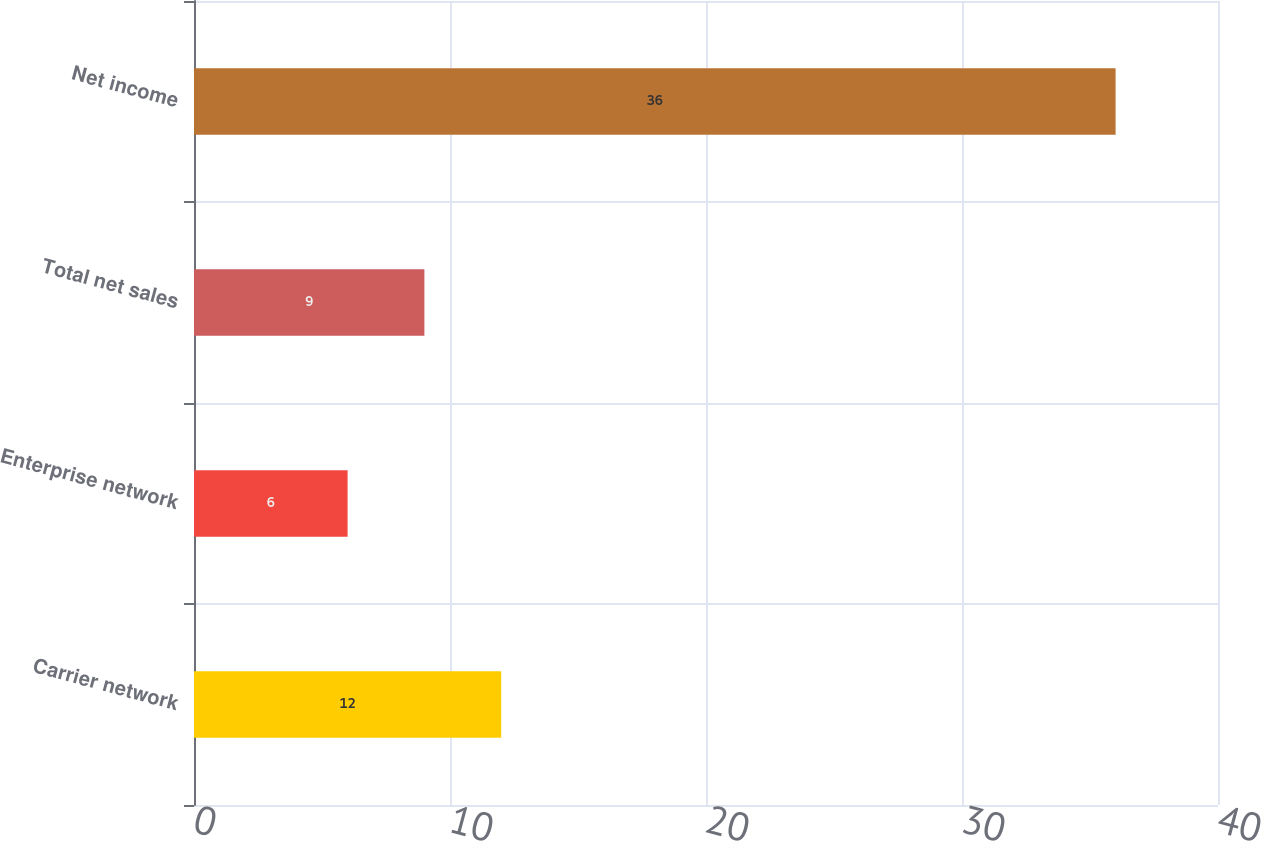Convert chart to OTSL. <chart><loc_0><loc_0><loc_500><loc_500><bar_chart><fcel>Carrier network<fcel>Enterprise network<fcel>Total net sales<fcel>Net income<nl><fcel>12<fcel>6<fcel>9<fcel>36<nl></chart> 